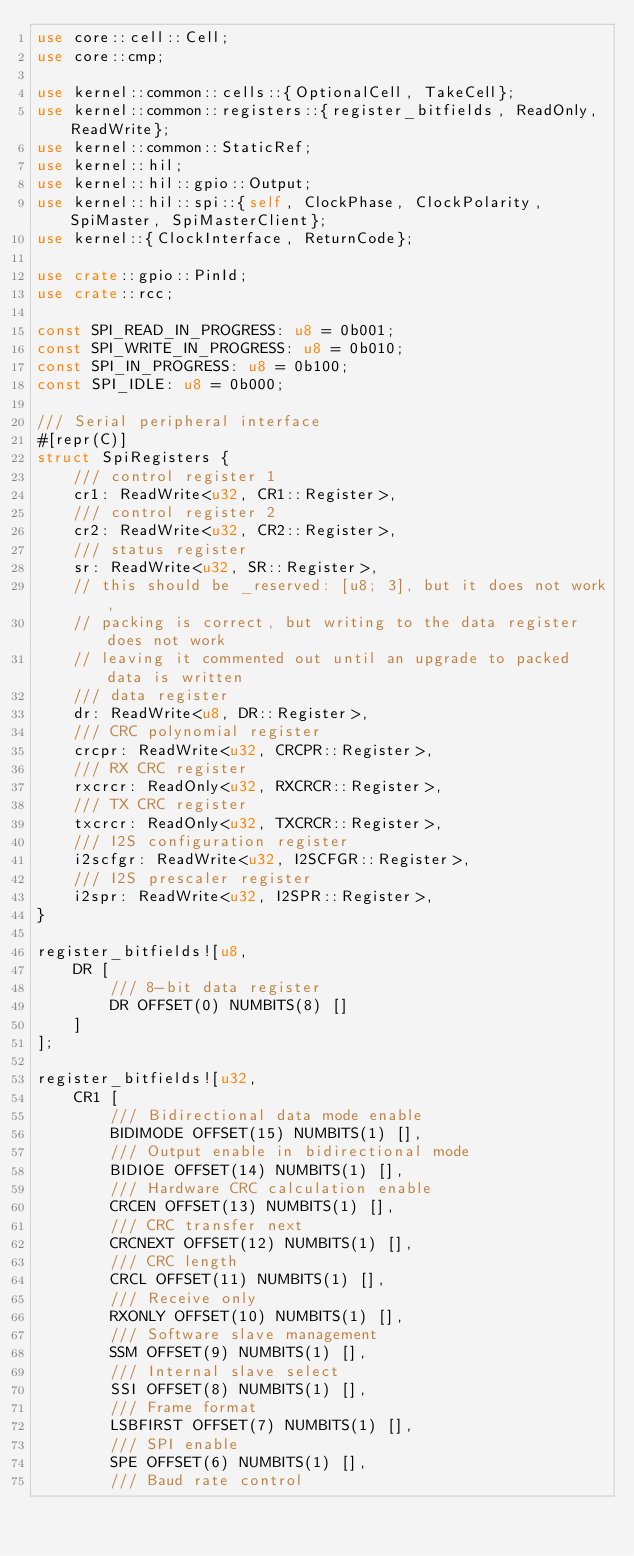Convert code to text. <code><loc_0><loc_0><loc_500><loc_500><_Rust_>use core::cell::Cell;
use core::cmp;

use kernel::common::cells::{OptionalCell, TakeCell};
use kernel::common::registers::{register_bitfields, ReadOnly, ReadWrite};
use kernel::common::StaticRef;
use kernel::hil;
use kernel::hil::gpio::Output;
use kernel::hil::spi::{self, ClockPhase, ClockPolarity, SpiMaster, SpiMasterClient};
use kernel::{ClockInterface, ReturnCode};

use crate::gpio::PinId;
use crate::rcc;

const SPI_READ_IN_PROGRESS: u8 = 0b001;
const SPI_WRITE_IN_PROGRESS: u8 = 0b010;
const SPI_IN_PROGRESS: u8 = 0b100;
const SPI_IDLE: u8 = 0b000;

/// Serial peripheral interface
#[repr(C)]
struct SpiRegisters {
    /// control register 1
    cr1: ReadWrite<u32, CR1::Register>,
    /// control register 2
    cr2: ReadWrite<u32, CR2::Register>,
    /// status register
    sr: ReadWrite<u32, SR::Register>,
    // this should be _reserved: [u8; 3], but it does not work,
    // packing is correct, but writing to the data register does not work
    // leaving it commented out until an upgrade to packed data is written
    /// data register
    dr: ReadWrite<u8, DR::Register>,
    /// CRC polynomial register
    crcpr: ReadWrite<u32, CRCPR::Register>,
    /// RX CRC register
    rxcrcr: ReadOnly<u32, RXCRCR::Register>,
    /// TX CRC register
    txcrcr: ReadOnly<u32, TXCRCR::Register>,
    /// I2S configuration register
    i2scfgr: ReadWrite<u32, I2SCFGR::Register>,
    /// I2S prescaler register
    i2spr: ReadWrite<u32, I2SPR::Register>,
}

register_bitfields![u8,
    DR [
        /// 8-bit data register
        DR OFFSET(0) NUMBITS(8) []
    ]
];

register_bitfields![u32,
    CR1 [
        /// Bidirectional data mode enable
        BIDIMODE OFFSET(15) NUMBITS(1) [],
        /// Output enable in bidirectional mode
        BIDIOE OFFSET(14) NUMBITS(1) [],
        /// Hardware CRC calculation enable
        CRCEN OFFSET(13) NUMBITS(1) [],
        /// CRC transfer next
        CRCNEXT OFFSET(12) NUMBITS(1) [],
        /// CRC length
        CRCL OFFSET(11) NUMBITS(1) [],
        /// Receive only
        RXONLY OFFSET(10) NUMBITS(1) [],
        /// Software slave management
        SSM OFFSET(9) NUMBITS(1) [],
        /// Internal slave select
        SSI OFFSET(8) NUMBITS(1) [],
        /// Frame format
        LSBFIRST OFFSET(7) NUMBITS(1) [],
        /// SPI enable
        SPE OFFSET(6) NUMBITS(1) [],
        /// Baud rate control</code> 